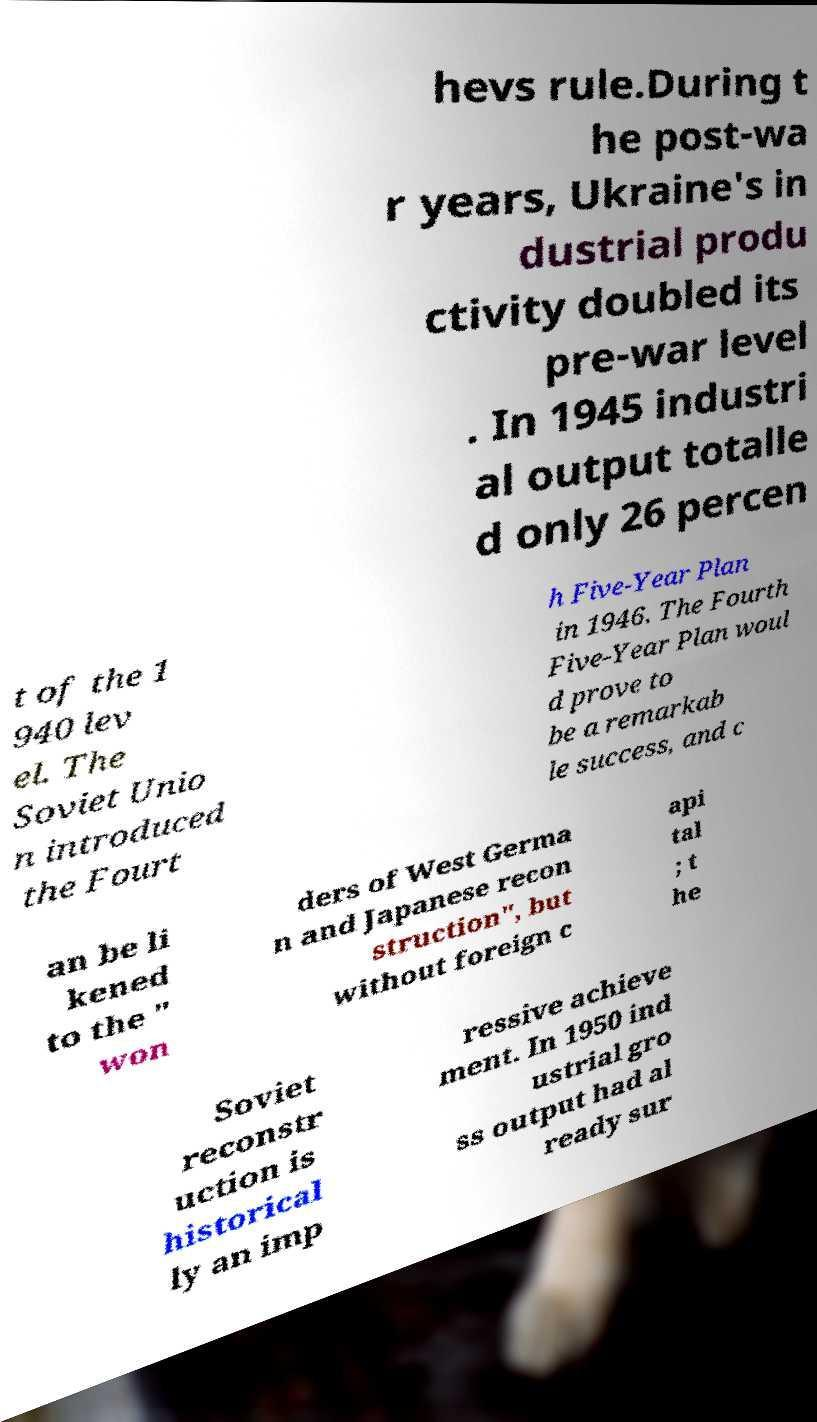Please identify and transcribe the text found in this image. hevs rule.During t he post-wa r years, Ukraine's in dustrial produ ctivity doubled its pre-war level . In 1945 industri al output totalle d only 26 percen t of the 1 940 lev el. The Soviet Unio n introduced the Fourt h Five-Year Plan in 1946. The Fourth Five-Year Plan woul d prove to be a remarkab le success, and c an be li kened to the " won ders of West Germa n and Japanese recon struction", but without foreign c api tal ; t he Soviet reconstr uction is historical ly an imp ressive achieve ment. In 1950 ind ustrial gro ss output had al ready sur 